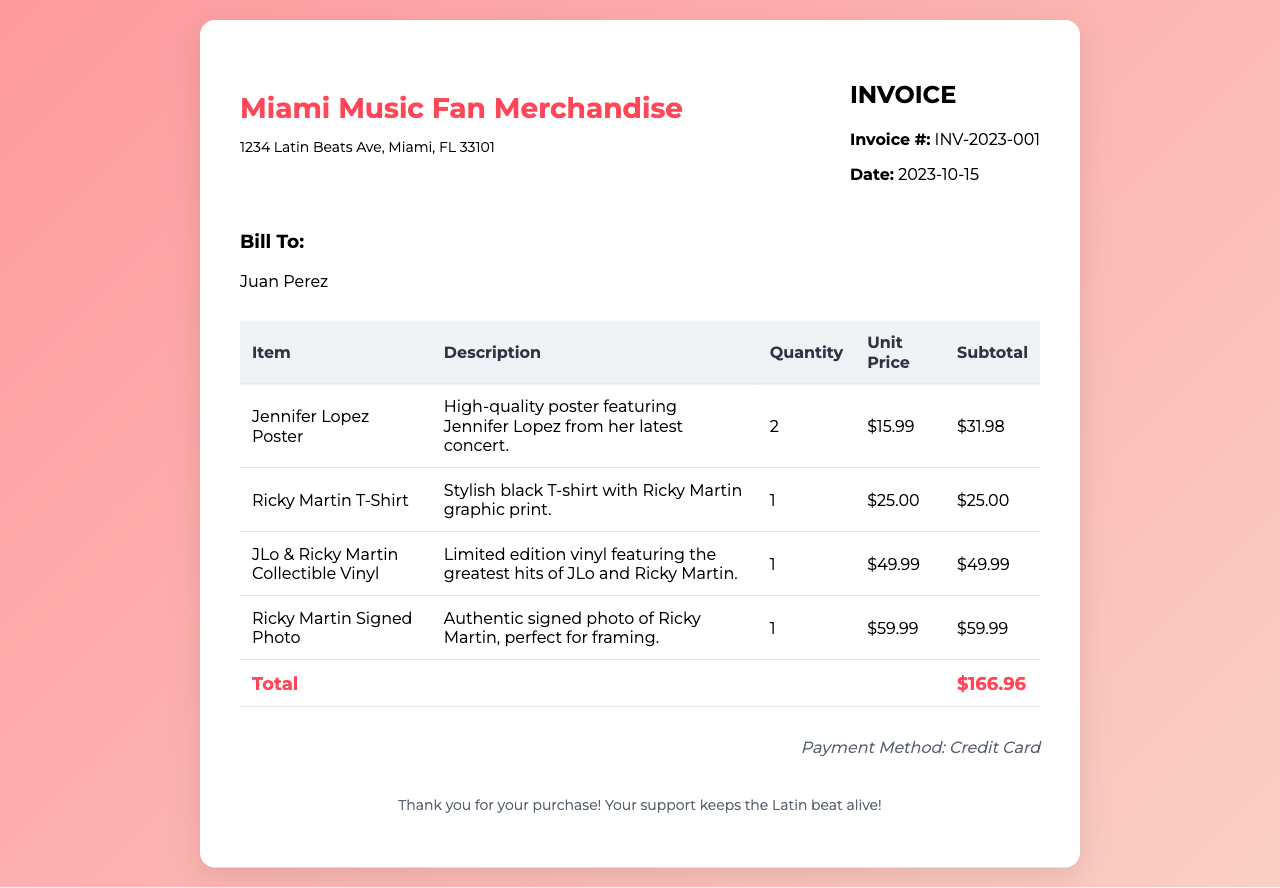What is the invoice number? The invoice number is specified clearly in the document, labeled as "Invoice #".
Answer: INV-2023-001 What is the date of the invoice? The date of the invoice is mentioned next to the invoice number.
Answer: 2023-10-15 Who is the bill to? The name of the person receiving the bill is stated under the "Bill To" section.
Answer: Juan Perez What is the subtotal for the Ricky Martin signed photo? The subtotal for this item can be found in the subtotal column of the invoice table.
Answer: $59.99 How many Jennifer Lopez posters were purchased? The quantity of this item is provided in the quantity column under the corresponding item row.
Answer: 2 What is the total amount of the invoice? The total amount is shown in the total row, which sums up all items listed.
Answer: $166.96 What payment method was used? The payment method is indicated at the bottom of the invoice.
Answer: Credit Card What type of collectible is included in the purchase? This is mentioned in the description of one of the items in the invoice.
Answer: Vinyl What is the unit price of the Ricky Martin T-shirt? The unit price for this specific item is listed in the unit price column.
Answer: $25.00 